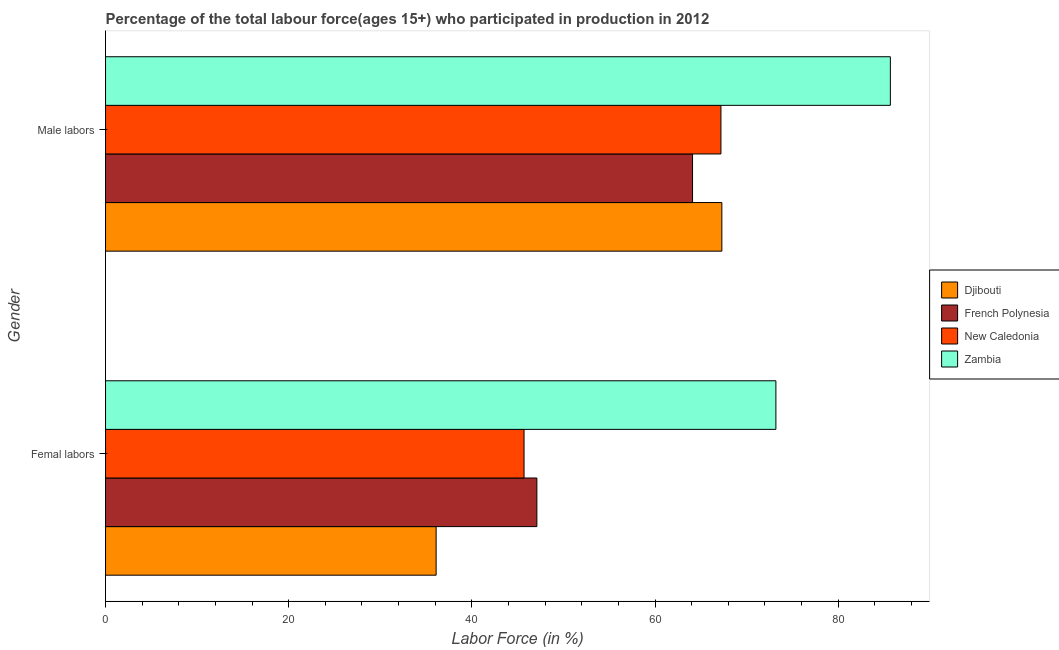How many different coloured bars are there?
Your answer should be very brief. 4. How many groups of bars are there?
Provide a short and direct response. 2. Are the number of bars per tick equal to the number of legend labels?
Make the answer very short. Yes. Are the number of bars on each tick of the Y-axis equal?
Ensure brevity in your answer.  Yes. What is the label of the 2nd group of bars from the top?
Offer a very short reply. Femal labors. What is the percentage of male labour force in Zambia?
Provide a short and direct response. 85.7. Across all countries, what is the maximum percentage of female labor force?
Make the answer very short. 73.2. Across all countries, what is the minimum percentage of male labour force?
Give a very brief answer. 64.1. In which country was the percentage of female labor force maximum?
Your answer should be compact. Zambia. In which country was the percentage of female labor force minimum?
Keep it short and to the point. Djibouti. What is the total percentage of female labor force in the graph?
Keep it short and to the point. 202.1. What is the difference between the percentage of male labour force in Djibouti and that in Zambia?
Make the answer very short. -18.4. What is the difference between the percentage of female labor force in French Polynesia and the percentage of male labour force in Zambia?
Provide a short and direct response. -38.6. What is the average percentage of male labour force per country?
Give a very brief answer. 71.07. What is the difference between the percentage of male labour force and percentage of female labor force in New Caledonia?
Ensure brevity in your answer.  21.5. In how many countries, is the percentage of female labor force greater than 60 %?
Your response must be concise. 1. What is the ratio of the percentage of female labor force in Zambia to that in Djibouti?
Keep it short and to the point. 2.03. Is the percentage of female labor force in New Caledonia less than that in Djibouti?
Make the answer very short. No. In how many countries, is the percentage of male labour force greater than the average percentage of male labour force taken over all countries?
Offer a terse response. 1. What does the 3rd bar from the top in Femal labors represents?
Offer a terse response. French Polynesia. What does the 2nd bar from the bottom in Male labors represents?
Provide a short and direct response. French Polynesia. How many countries are there in the graph?
Keep it short and to the point. 4. Are the values on the major ticks of X-axis written in scientific E-notation?
Provide a short and direct response. No. Does the graph contain any zero values?
Your answer should be very brief. No. Does the graph contain grids?
Offer a terse response. No. What is the title of the graph?
Your response must be concise. Percentage of the total labour force(ages 15+) who participated in production in 2012. Does "Sudan" appear as one of the legend labels in the graph?
Give a very brief answer. No. What is the Labor Force (in %) of Djibouti in Femal labors?
Your response must be concise. 36.1. What is the Labor Force (in %) in French Polynesia in Femal labors?
Your answer should be very brief. 47.1. What is the Labor Force (in %) in New Caledonia in Femal labors?
Ensure brevity in your answer.  45.7. What is the Labor Force (in %) in Zambia in Femal labors?
Your response must be concise. 73.2. What is the Labor Force (in %) of Djibouti in Male labors?
Make the answer very short. 67.3. What is the Labor Force (in %) of French Polynesia in Male labors?
Give a very brief answer. 64.1. What is the Labor Force (in %) in New Caledonia in Male labors?
Give a very brief answer. 67.2. What is the Labor Force (in %) of Zambia in Male labors?
Keep it short and to the point. 85.7. Across all Gender, what is the maximum Labor Force (in %) in Djibouti?
Your answer should be very brief. 67.3. Across all Gender, what is the maximum Labor Force (in %) of French Polynesia?
Keep it short and to the point. 64.1. Across all Gender, what is the maximum Labor Force (in %) in New Caledonia?
Offer a terse response. 67.2. Across all Gender, what is the maximum Labor Force (in %) of Zambia?
Offer a terse response. 85.7. Across all Gender, what is the minimum Labor Force (in %) of Djibouti?
Keep it short and to the point. 36.1. Across all Gender, what is the minimum Labor Force (in %) of French Polynesia?
Offer a terse response. 47.1. Across all Gender, what is the minimum Labor Force (in %) of New Caledonia?
Ensure brevity in your answer.  45.7. Across all Gender, what is the minimum Labor Force (in %) in Zambia?
Offer a terse response. 73.2. What is the total Labor Force (in %) in Djibouti in the graph?
Your answer should be compact. 103.4. What is the total Labor Force (in %) in French Polynesia in the graph?
Offer a terse response. 111.2. What is the total Labor Force (in %) of New Caledonia in the graph?
Keep it short and to the point. 112.9. What is the total Labor Force (in %) of Zambia in the graph?
Offer a very short reply. 158.9. What is the difference between the Labor Force (in %) in Djibouti in Femal labors and that in Male labors?
Offer a terse response. -31.2. What is the difference between the Labor Force (in %) in French Polynesia in Femal labors and that in Male labors?
Your response must be concise. -17. What is the difference between the Labor Force (in %) in New Caledonia in Femal labors and that in Male labors?
Your response must be concise. -21.5. What is the difference between the Labor Force (in %) in Djibouti in Femal labors and the Labor Force (in %) in New Caledonia in Male labors?
Your response must be concise. -31.1. What is the difference between the Labor Force (in %) in Djibouti in Femal labors and the Labor Force (in %) in Zambia in Male labors?
Your response must be concise. -49.6. What is the difference between the Labor Force (in %) of French Polynesia in Femal labors and the Labor Force (in %) of New Caledonia in Male labors?
Ensure brevity in your answer.  -20.1. What is the difference between the Labor Force (in %) in French Polynesia in Femal labors and the Labor Force (in %) in Zambia in Male labors?
Make the answer very short. -38.6. What is the difference between the Labor Force (in %) of New Caledonia in Femal labors and the Labor Force (in %) of Zambia in Male labors?
Make the answer very short. -40. What is the average Labor Force (in %) in Djibouti per Gender?
Keep it short and to the point. 51.7. What is the average Labor Force (in %) of French Polynesia per Gender?
Make the answer very short. 55.6. What is the average Labor Force (in %) of New Caledonia per Gender?
Your response must be concise. 56.45. What is the average Labor Force (in %) in Zambia per Gender?
Give a very brief answer. 79.45. What is the difference between the Labor Force (in %) of Djibouti and Labor Force (in %) of French Polynesia in Femal labors?
Keep it short and to the point. -11. What is the difference between the Labor Force (in %) in Djibouti and Labor Force (in %) in Zambia in Femal labors?
Provide a short and direct response. -37.1. What is the difference between the Labor Force (in %) in French Polynesia and Labor Force (in %) in New Caledonia in Femal labors?
Give a very brief answer. 1.4. What is the difference between the Labor Force (in %) of French Polynesia and Labor Force (in %) of Zambia in Femal labors?
Keep it short and to the point. -26.1. What is the difference between the Labor Force (in %) of New Caledonia and Labor Force (in %) of Zambia in Femal labors?
Your answer should be very brief. -27.5. What is the difference between the Labor Force (in %) in Djibouti and Labor Force (in %) in French Polynesia in Male labors?
Provide a succinct answer. 3.2. What is the difference between the Labor Force (in %) in Djibouti and Labor Force (in %) in New Caledonia in Male labors?
Offer a terse response. 0.1. What is the difference between the Labor Force (in %) in Djibouti and Labor Force (in %) in Zambia in Male labors?
Your answer should be compact. -18.4. What is the difference between the Labor Force (in %) in French Polynesia and Labor Force (in %) in New Caledonia in Male labors?
Give a very brief answer. -3.1. What is the difference between the Labor Force (in %) in French Polynesia and Labor Force (in %) in Zambia in Male labors?
Give a very brief answer. -21.6. What is the difference between the Labor Force (in %) in New Caledonia and Labor Force (in %) in Zambia in Male labors?
Your response must be concise. -18.5. What is the ratio of the Labor Force (in %) in Djibouti in Femal labors to that in Male labors?
Keep it short and to the point. 0.54. What is the ratio of the Labor Force (in %) of French Polynesia in Femal labors to that in Male labors?
Make the answer very short. 0.73. What is the ratio of the Labor Force (in %) of New Caledonia in Femal labors to that in Male labors?
Offer a very short reply. 0.68. What is the ratio of the Labor Force (in %) of Zambia in Femal labors to that in Male labors?
Make the answer very short. 0.85. What is the difference between the highest and the second highest Labor Force (in %) in Djibouti?
Your answer should be compact. 31.2. What is the difference between the highest and the second highest Labor Force (in %) in French Polynesia?
Keep it short and to the point. 17. What is the difference between the highest and the second highest Labor Force (in %) of Zambia?
Provide a succinct answer. 12.5. What is the difference between the highest and the lowest Labor Force (in %) in Djibouti?
Your response must be concise. 31.2. What is the difference between the highest and the lowest Labor Force (in %) of Zambia?
Your response must be concise. 12.5. 